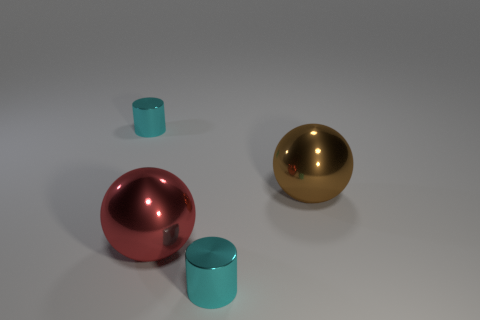Add 3 large purple metallic spheres. How many objects exist? 7 Subtract 0 purple blocks. How many objects are left? 4 Subtract all small things. Subtract all tiny cyan objects. How many objects are left? 0 Add 4 big brown metallic things. How many big brown metallic things are left? 5 Add 2 large shiny things. How many large shiny things exist? 4 